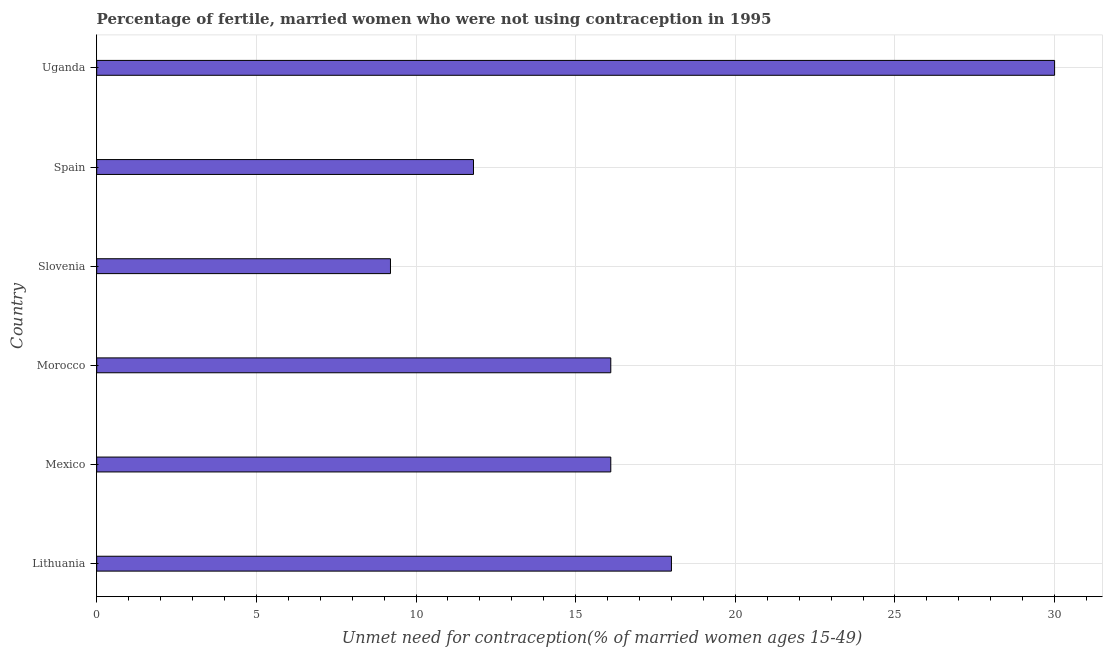Does the graph contain grids?
Keep it short and to the point. Yes. What is the title of the graph?
Offer a terse response. Percentage of fertile, married women who were not using contraception in 1995. What is the label or title of the X-axis?
Offer a terse response.  Unmet need for contraception(% of married women ages 15-49). Across all countries, what is the maximum number of married women who are not using contraception?
Your answer should be compact. 30. In which country was the number of married women who are not using contraception maximum?
Offer a terse response. Uganda. In which country was the number of married women who are not using contraception minimum?
Make the answer very short. Slovenia. What is the sum of the number of married women who are not using contraception?
Your answer should be very brief. 101.2. What is the difference between the number of married women who are not using contraception in Slovenia and Spain?
Provide a succinct answer. -2.6. What is the average number of married women who are not using contraception per country?
Your answer should be very brief. 16.87. In how many countries, is the number of married women who are not using contraception greater than 28 %?
Provide a short and direct response. 1. What is the ratio of the number of married women who are not using contraception in Lithuania to that in Spain?
Offer a terse response. 1.52. What is the difference between the highest and the second highest number of married women who are not using contraception?
Make the answer very short. 12. What is the difference between the highest and the lowest number of married women who are not using contraception?
Provide a short and direct response. 20.8. Are all the bars in the graph horizontal?
Your answer should be compact. Yes. Are the values on the major ticks of X-axis written in scientific E-notation?
Give a very brief answer. No. What is the  Unmet need for contraception(% of married women ages 15-49) of Lithuania?
Your answer should be compact. 18. What is the  Unmet need for contraception(% of married women ages 15-49) of Slovenia?
Offer a terse response. 9.2. What is the  Unmet need for contraception(% of married women ages 15-49) of Uganda?
Offer a terse response. 30. What is the difference between the  Unmet need for contraception(% of married women ages 15-49) in Lithuania and Mexico?
Keep it short and to the point. 1.9. What is the difference between the  Unmet need for contraception(% of married women ages 15-49) in Lithuania and Morocco?
Make the answer very short. 1.9. What is the difference between the  Unmet need for contraception(% of married women ages 15-49) in Lithuania and Spain?
Your response must be concise. 6.2. What is the difference between the  Unmet need for contraception(% of married women ages 15-49) in Mexico and Slovenia?
Your response must be concise. 6.9. What is the difference between the  Unmet need for contraception(% of married women ages 15-49) in Mexico and Uganda?
Keep it short and to the point. -13.9. What is the difference between the  Unmet need for contraception(% of married women ages 15-49) in Morocco and Spain?
Provide a short and direct response. 4.3. What is the difference between the  Unmet need for contraception(% of married women ages 15-49) in Morocco and Uganda?
Give a very brief answer. -13.9. What is the difference between the  Unmet need for contraception(% of married women ages 15-49) in Slovenia and Uganda?
Make the answer very short. -20.8. What is the difference between the  Unmet need for contraception(% of married women ages 15-49) in Spain and Uganda?
Ensure brevity in your answer.  -18.2. What is the ratio of the  Unmet need for contraception(% of married women ages 15-49) in Lithuania to that in Mexico?
Your response must be concise. 1.12. What is the ratio of the  Unmet need for contraception(% of married women ages 15-49) in Lithuania to that in Morocco?
Your answer should be compact. 1.12. What is the ratio of the  Unmet need for contraception(% of married women ages 15-49) in Lithuania to that in Slovenia?
Your answer should be compact. 1.96. What is the ratio of the  Unmet need for contraception(% of married women ages 15-49) in Lithuania to that in Spain?
Provide a short and direct response. 1.52. What is the ratio of the  Unmet need for contraception(% of married women ages 15-49) in Lithuania to that in Uganda?
Provide a succinct answer. 0.6. What is the ratio of the  Unmet need for contraception(% of married women ages 15-49) in Mexico to that in Morocco?
Ensure brevity in your answer.  1. What is the ratio of the  Unmet need for contraception(% of married women ages 15-49) in Mexico to that in Spain?
Your response must be concise. 1.36. What is the ratio of the  Unmet need for contraception(% of married women ages 15-49) in Mexico to that in Uganda?
Keep it short and to the point. 0.54. What is the ratio of the  Unmet need for contraception(% of married women ages 15-49) in Morocco to that in Slovenia?
Keep it short and to the point. 1.75. What is the ratio of the  Unmet need for contraception(% of married women ages 15-49) in Morocco to that in Spain?
Offer a very short reply. 1.36. What is the ratio of the  Unmet need for contraception(% of married women ages 15-49) in Morocco to that in Uganda?
Offer a very short reply. 0.54. What is the ratio of the  Unmet need for contraception(% of married women ages 15-49) in Slovenia to that in Spain?
Make the answer very short. 0.78. What is the ratio of the  Unmet need for contraception(% of married women ages 15-49) in Slovenia to that in Uganda?
Offer a very short reply. 0.31. What is the ratio of the  Unmet need for contraception(% of married women ages 15-49) in Spain to that in Uganda?
Provide a short and direct response. 0.39. 